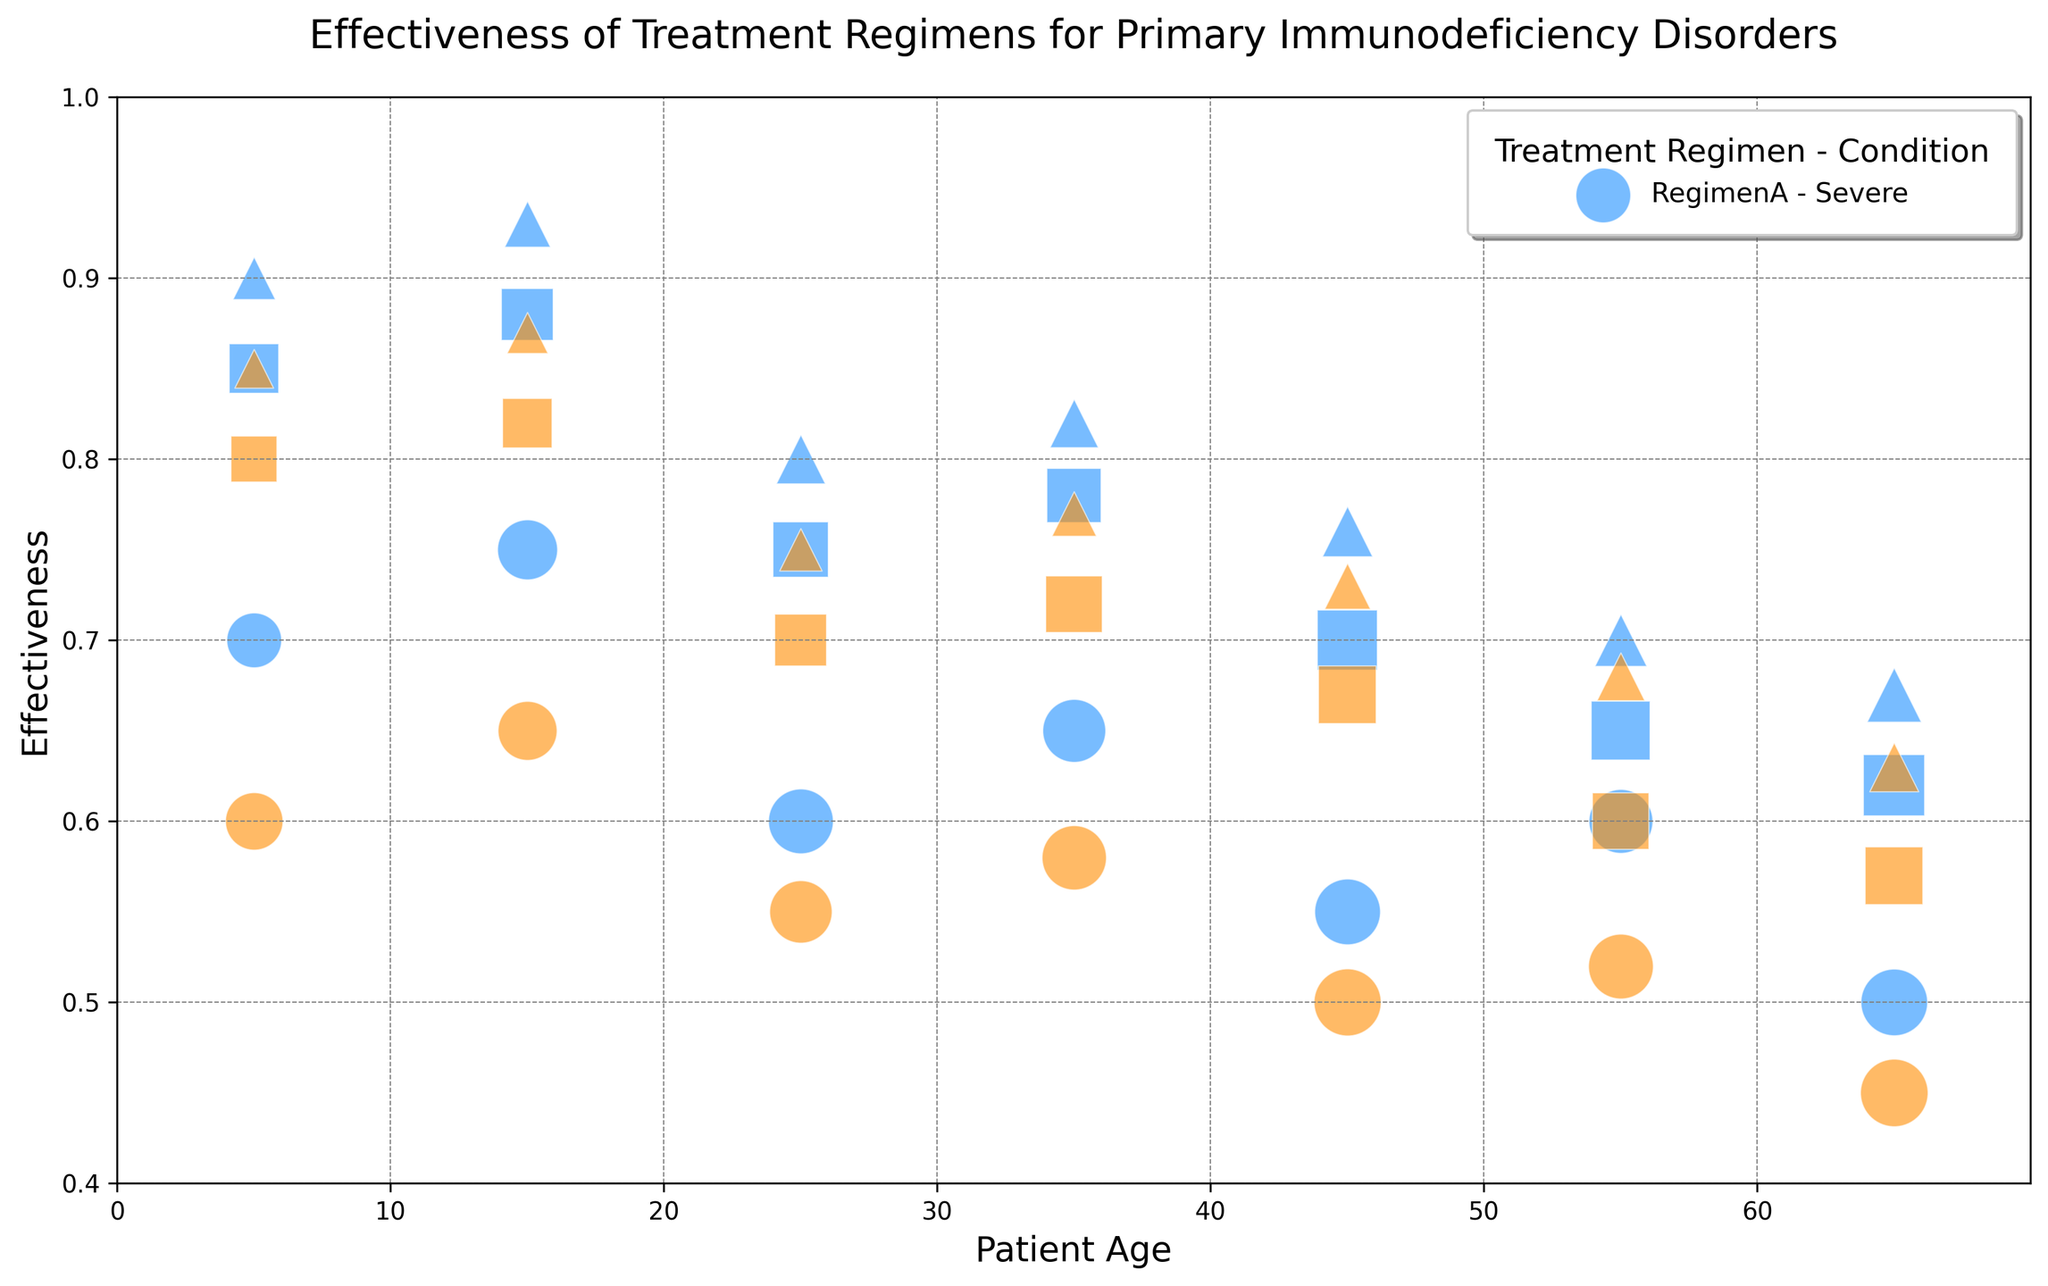What's the overall trend in the effectiveness of Regimen A across different patient ages? To determine the overall trend, observe the position of the bubbles representing Regimen A on the y-axis as the patient age on the x-axis increases. The bubbles gradually decrease in height (y-axis position) as age increases, indicating a decrease in effectiveness.
Answer: Decreasing Which baseline health condition shows the highest effectiveness for Regimen B at age 5? Look at the bubbles for age 5 (x-axis) colored for Regimen B (dark orange) and compare their positions on the y-axis. The highest bubble corresponds to Mild baseline health condition.
Answer: Mild What is the difference in effectiveness between Regimen A and Regimen B for severe baseline health condition in patients aged 15? Identify the bubbles for patients aged 15 with severe baseline health condition (elliptical markers) for both regimens. The effectiveness for Regimen A is 0.75 and for Regimen B is 0.65, thus the difference is 0.75 - 0.65.
Answer: 0.10 Among patients with severe baseline health condition, which regimen has the larger sample size at age 45? Check the size of the elliptical markers for age 45 (x-axis) with severe baseline health conditions, noting their marker size. Regimen B (dark orange bubble) is larger.
Answer: Regimen B Comparing moderate baseline health condition between ages 25 and 35, which age group shows a higher effectiveness for Regimen A? Examine the square markers for Regimen A (blue) for ages 25 and 35 and note their y-axis positions. Age 35 shows a higher effectiveness (0.78) compared to age 25 (0.75).
Answer: Age 35 How does the effectiveness of Regimen B for mild baseline health conditions change from age 25 to age 65? Observe the triangular markers in dark orange color for ages 25 and 65 and compare their heights. The effectiveness decreases from 0.75 to 0.63.
Answer: Decreases What's the average effectiveness of Regimen A for moderate baseline health conditions across all ages? Extract the effectiveness values for moderate conditions (square markers) under Regimen A across all ages (0.85, 0.88, 0.75, 0.78, 0.70, 0.65, 0.62). Calculate the average: (0.85 + 0.88 + 0.75 + 0.78 + 0.70 + 0.65 + 0.62) / 7.
Answer: 0.75 For a 35-year-old patient with a mild baseline health condition, which treatment regimen has a higher effectiveness? Compare the positions of the triangular markers for age 35 in both colors. The blue marker (Regimen A) is higher on the y-axis than the dark orange marker (Regimen B).
Answer: Regimen A Among the bubbles for age 15, which baseline health condition under Regimen A shows the highest effectiveness? Look at the blue bubbles for age 15 and compare their y-axis positions. The highest bubble represents Mild baseline health condition.
Answer: Mild 